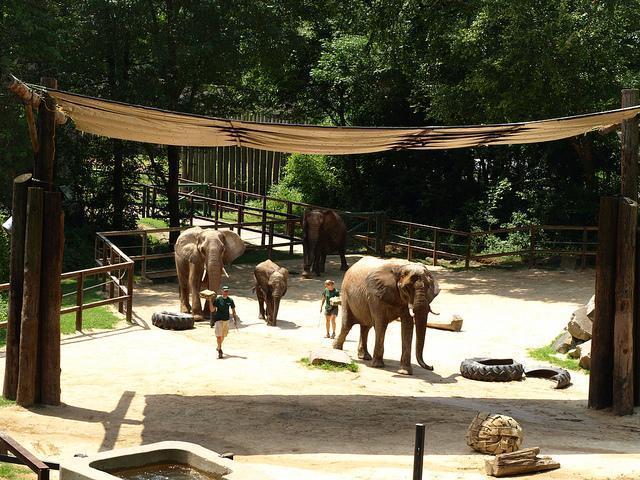How many elephants in the image?
Give a very brief answer. 4. How many elephants are in the picture?
Give a very brief answer. 3. 